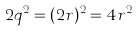<formula> <loc_0><loc_0><loc_500><loc_500>2 q ^ { 2 } = ( 2 r ) ^ { 2 } = 4 r ^ { 2 }</formula> 